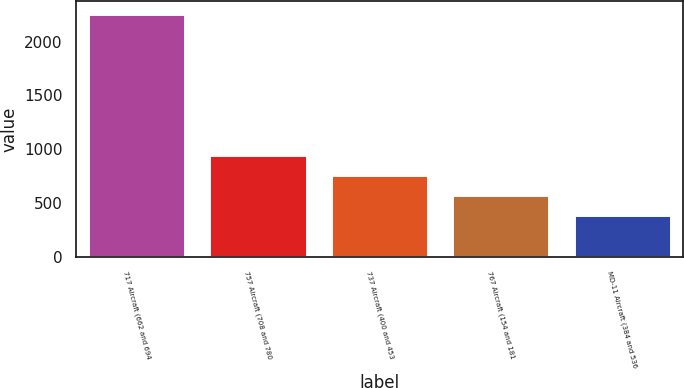Convert chart. <chart><loc_0><loc_0><loc_500><loc_500><bar_chart><fcel>717 Aircraft (662 and 694<fcel>757 Aircraft (708 and 780<fcel>737 Aircraft (400 and 453<fcel>767 Aircraft (154 and 181<fcel>MD-11 Aircraft (384 and 536<nl><fcel>2262<fcel>947.4<fcel>759.6<fcel>571.8<fcel>384<nl></chart> 